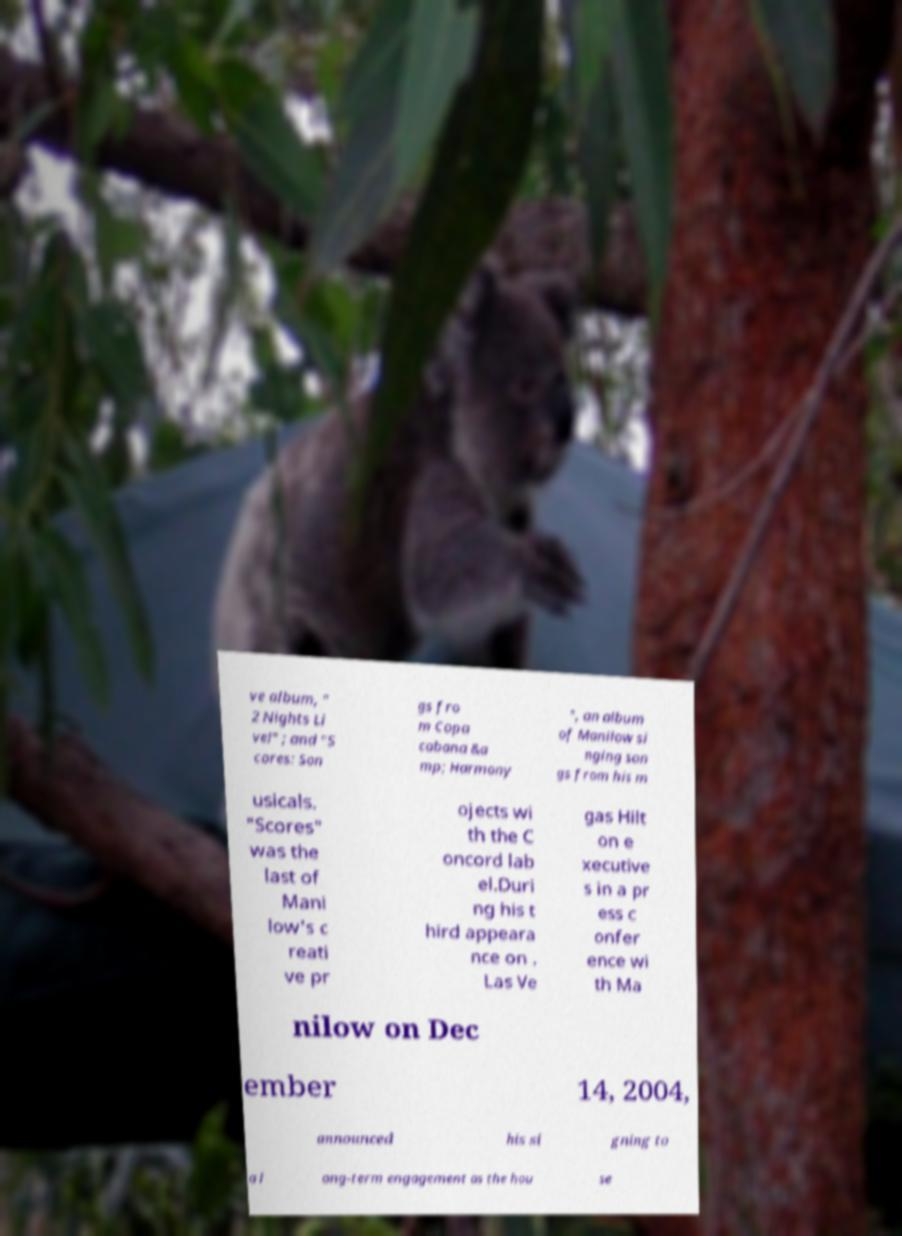Can you read and provide the text displayed in the image?This photo seems to have some interesting text. Can you extract and type it out for me? ve album, " 2 Nights Li ve!" ; and "S cores: Son gs fro m Copa cabana &a mp; Harmony ", an album of Manilow si nging son gs from his m usicals. "Scores" was the last of Mani low's c reati ve pr ojects wi th the C oncord lab el.Duri ng his t hird appeara nce on . Las Ve gas Hilt on e xecutive s in a pr ess c onfer ence wi th Ma nilow on Dec ember 14, 2004, announced his si gning to a l ong-term engagement as the hou se 